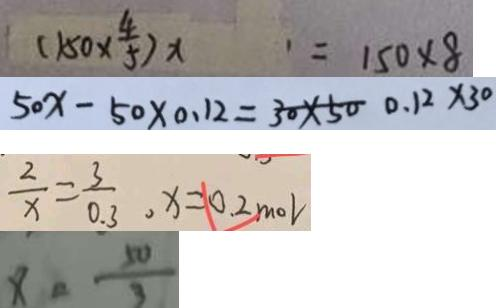Convert formula to latex. <formula><loc_0><loc_0><loc_500><loc_500>( 1 5 0 \times \frac { 4 } { 5 } ) x = 1 5 0 \times 8 
 5 0 x - 5 0 \times 0 . 1 2 = 3 0 \times 5 0 . 1 2 \times 3 0 
 \frac { 2 } { x } = \frac { 3 } { 0 . 3 } , x = 0 . 2 m o l 
 x = \frac { 5 0 } { 3 }</formula> 